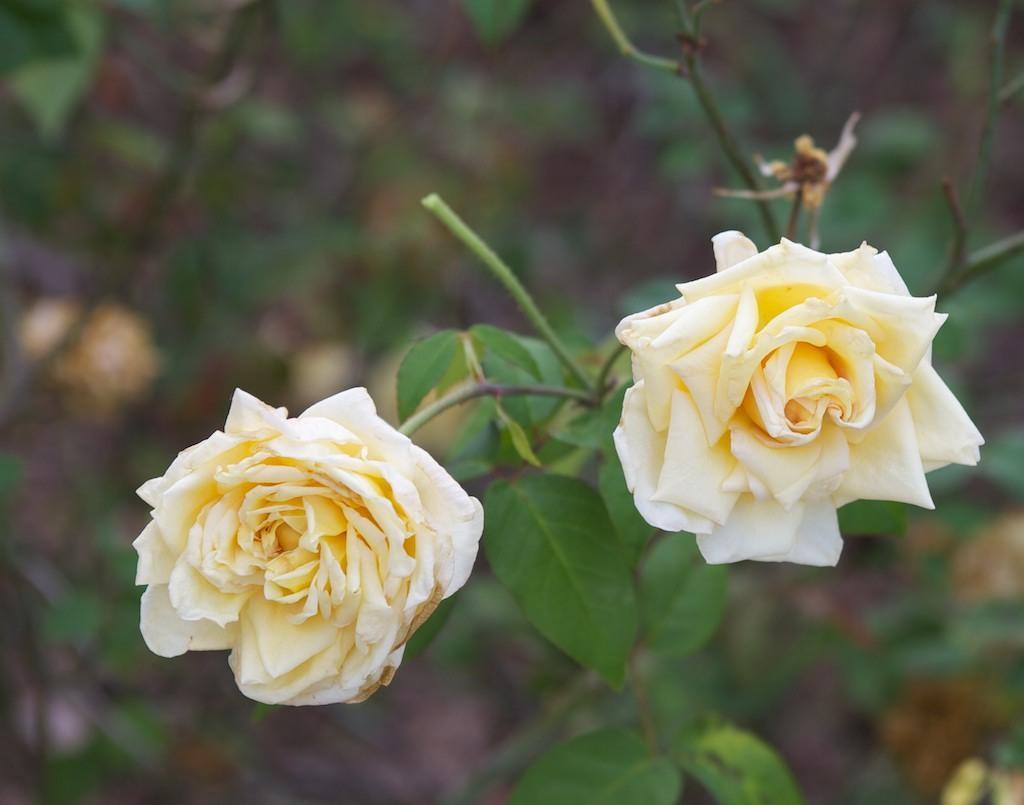In one or two sentences, can you explain what this image depicts? In this image I can see few leaves and few white colour flowers in the front. I can also see this image is little bit blurry in the background. 